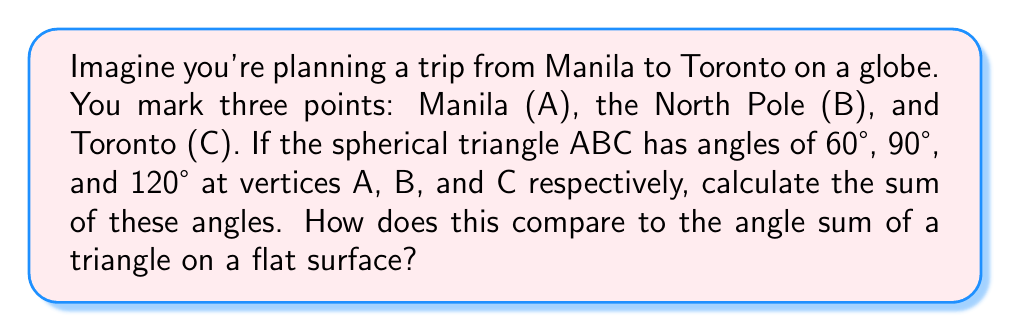Help me with this question. Let's approach this step-by-step:

1) In spherical geometry, triangles are formed by great circles on the surface of a sphere. Unlike in Euclidean geometry, the sum of angles in a spherical triangle is always greater than 180°.

2) The formula for the angle sum of a spherical triangle is:

   $$S = \alpha + \beta + \gamma - 180°$$

   Where $S$ is the spherical excess, and $\alpha$, $\beta$, and $\gamma$ are the angles of the triangle.

3) In our case:
   $\alpha = 60°$
   $\beta = 90°$
   $\gamma = 120°$

4) Let's sum these angles:

   $$60° + 90° + 120° = 270°$$

5) We can verify using the spherical excess formula:

   $$S = (60° + 90° + 120°) - 180° = 270° - 180° = 90°$$

6) The spherical excess is 90°, which means the sum of angles exceeds 180° by 90°.

7) Comparison to a flat surface:
   - On a flat (Euclidean) surface, the sum of angles in a triangle is always 180°.
   - On our spherical surface, the sum is 270°, which is 90° more than on a flat surface.

This difference is due to the curvature of the spherical surface, which affects the geometry of shapes drawn on it.
Answer: 270°; 90° more than a flat triangle 